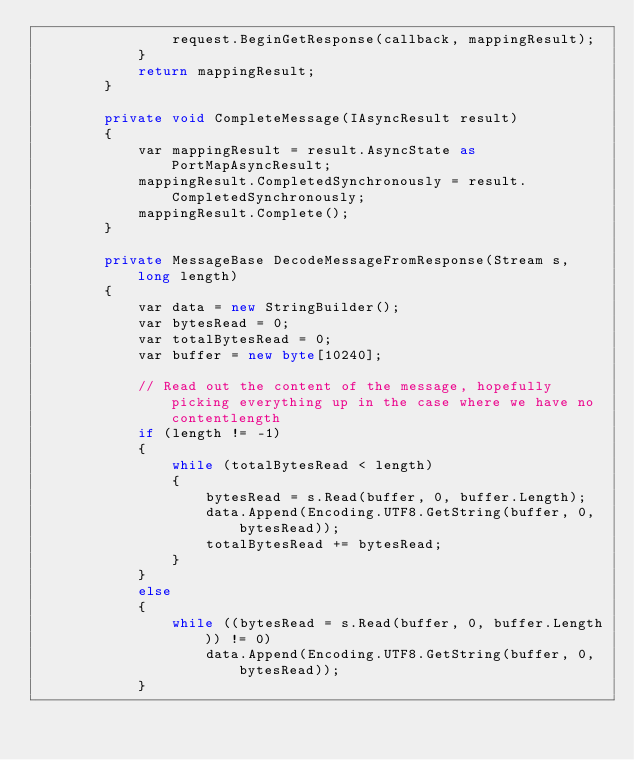<code> <loc_0><loc_0><loc_500><loc_500><_C#_>				request.BeginGetResponse(callback, mappingResult);
			}
			return mappingResult;
		}

		private void CompleteMessage(IAsyncResult result)
		{
			var mappingResult = result.AsyncState as PortMapAsyncResult;
			mappingResult.CompletedSynchronously = result.CompletedSynchronously;
            mappingResult.Complete();
		}

		private MessageBase DecodeMessageFromResponse(Stream s, long length)
		{
			var data = new StringBuilder();
			var bytesRead = 0;
			var totalBytesRead = 0;
			var buffer = new byte[10240];

			// Read out the content of the message, hopefully picking everything up in the case where we have no contentlength
			if (length != -1)
			{
				while (totalBytesRead < length)
				{
					bytesRead = s.Read(buffer, 0, buffer.Length);
					data.Append(Encoding.UTF8.GetString(buffer, 0, bytesRead));
					totalBytesRead += bytesRead;
				}
			}
			else
			{
				while ((bytesRead = s.Read(buffer, 0, buffer.Length)) != 0)
					data.Append(Encoding.UTF8.GetString(buffer, 0, bytesRead));
			}
</code> 